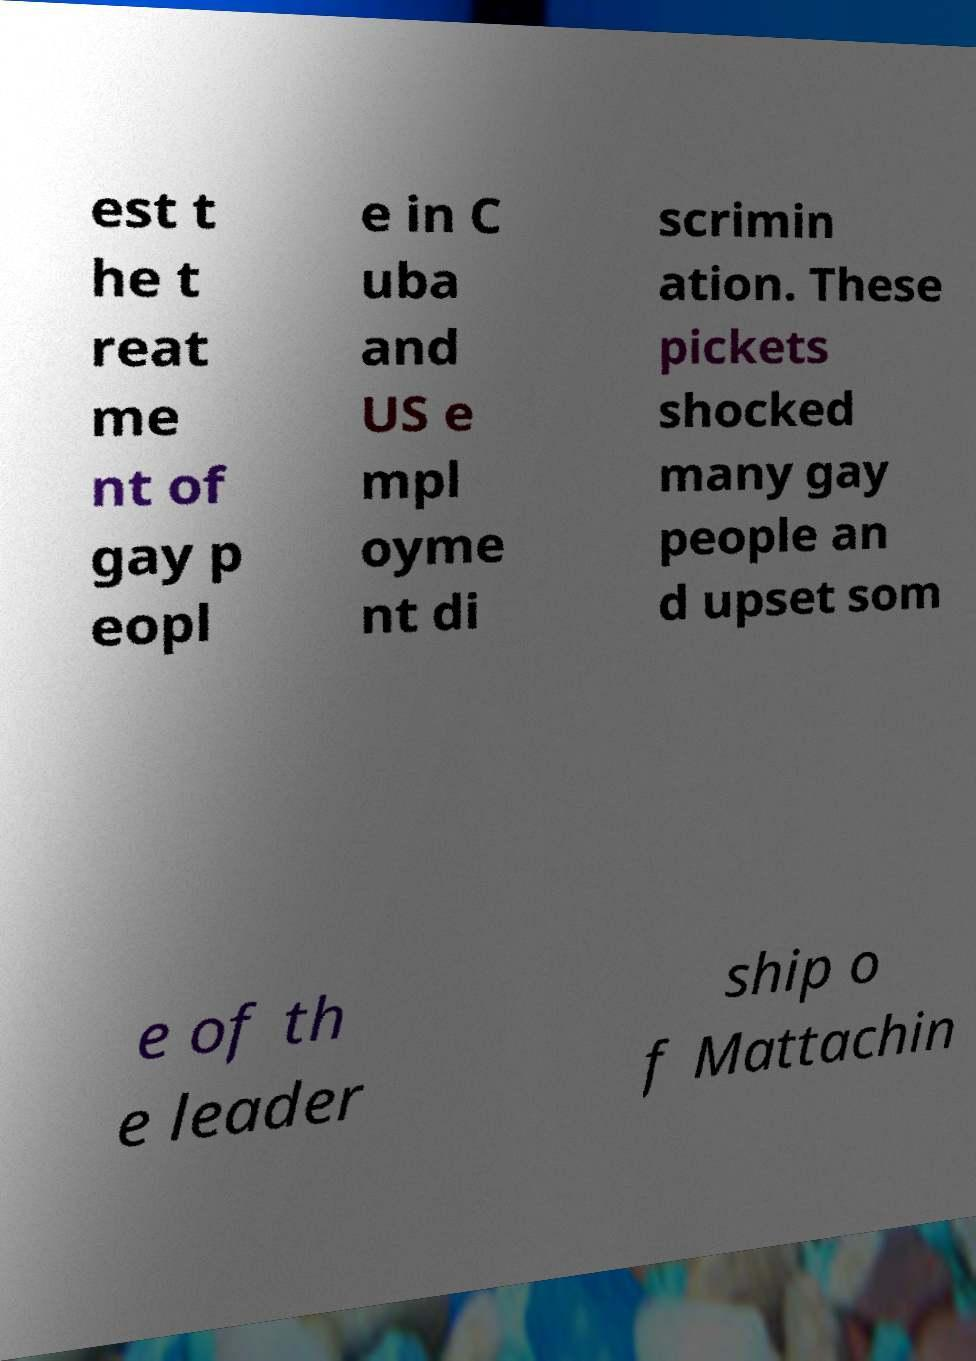What messages or text are displayed in this image? I need them in a readable, typed format. est t he t reat me nt of gay p eopl e in C uba and US e mpl oyme nt di scrimin ation. These pickets shocked many gay people an d upset som e of th e leader ship o f Mattachin 